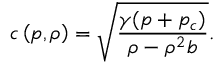<formula> <loc_0><loc_0><loc_500><loc_500>c \left ( p , \rho \right ) = \sqrt { \frac { \gamma ( p + p _ { c } ) } { \rho - \rho ^ { 2 } b } } .</formula> 